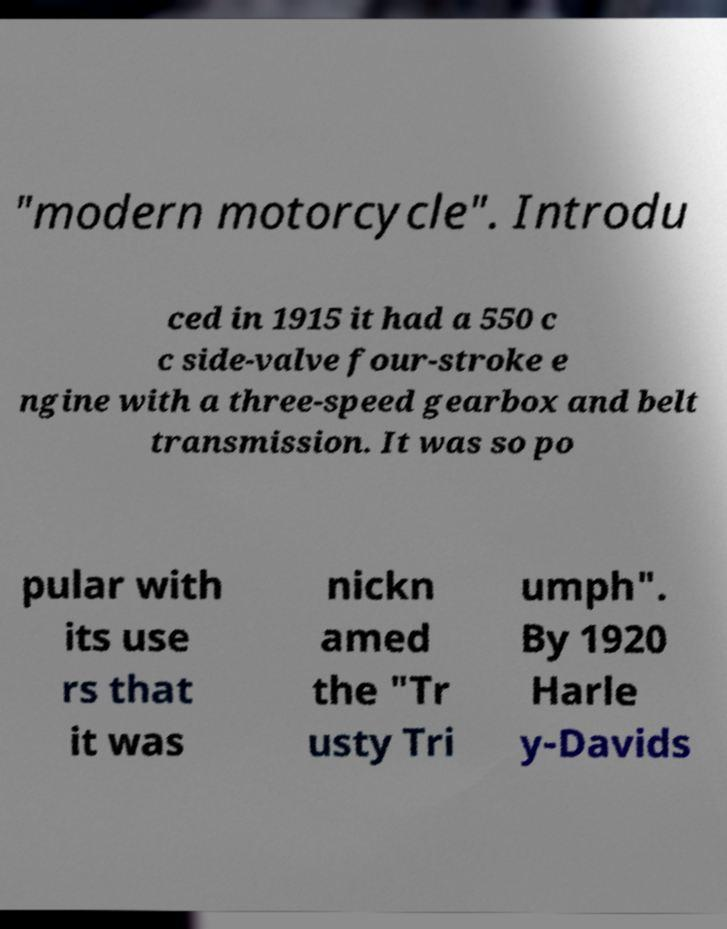What messages or text are displayed in this image? I need them in a readable, typed format. "modern motorcycle". Introdu ced in 1915 it had a 550 c c side-valve four-stroke e ngine with a three-speed gearbox and belt transmission. It was so po pular with its use rs that it was nickn amed the "Tr usty Tri umph". By 1920 Harle y-Davids 